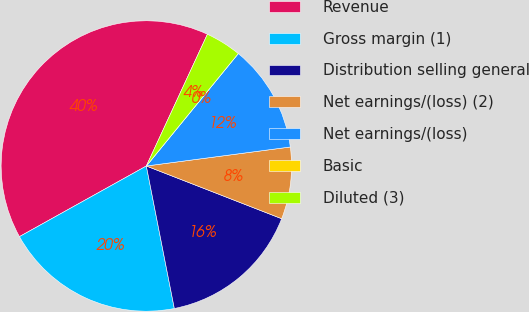<chart> <loc_0><loc_0><loc_500><loc_500><pie_chart><fcel>Revenue<fcel>Gross margin (1)<fcel>Distribution selling general<fcel>Net earnings/(loss) (2)<fcel>Net earnings/(loss)<fcel>Basic<fcel>Diluted (3)<nl><fcel>39.99%<fcel>20.0%<fcel>16.0%<fcel>8.0%<fcel>12.0%<fcel>0.0%<fcel>4.0%<nl></chart> 